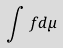Convert formula to latex. <formula><loc_0><loc_0><loc_500><loc_500>\int f d \mu</formula> 